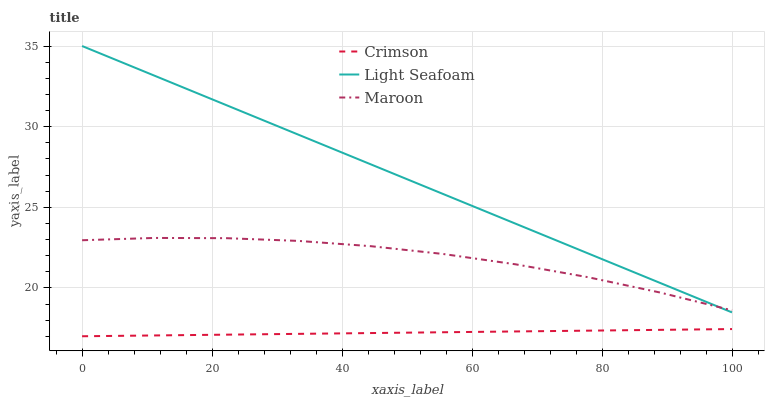Does Crimson have the minimum area under the curve?
Answer yes or no. Yes. Does Light Seafoam have the maximum area under the curve?
Answer yes or no. Yes. Does Maroon have the minimum area under the curve?
Answer yes or no. No. Does Maroon have the maximum area under the curve?
Answer yes or no. No. Is Crimson the smoothest?
Answer yes or no. Yes. Is Maroon the roughest?
Answer yes or no. Yes. Is Light Seafoam the smoothest?
Answer yes or no. No. Is Light Seafoam the roughest?
Answer yes or no. No. Does Crimson have the lowest value?
Answer yes or no. Yes. Does Light Seafoam have the lowest value?
Answer yes or no. No. Does Light Seafoam have the highest value?
Answer yes or no. Yes. Does Maroon have the highest value?
Answer yes or no. No. Is Crimson less than Light Seafoam?
Answer yes or no. Yes. Is Maroon greater than Crimson?
Answer yes or no. Yes. Does Maroon intersect Light Seafoam?
Answer yes or no. Yes. Is Maroon less than Light Seafoam?
Answer yes or no. No. Is Maroon greater than Light Seafoam?
Answer yes or no. No. Does Crimson intersect Light Seafoam?
Answer yes or no. No. 